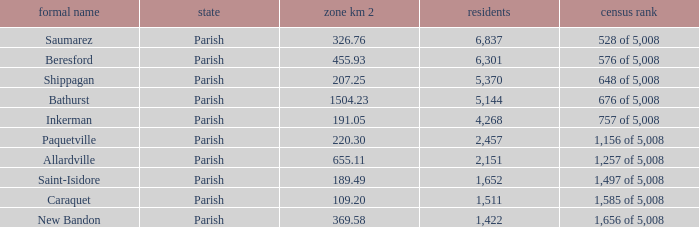What is the Area of the Saint-Isidore Parish with a Population smaller than 4,268? 189.49. 